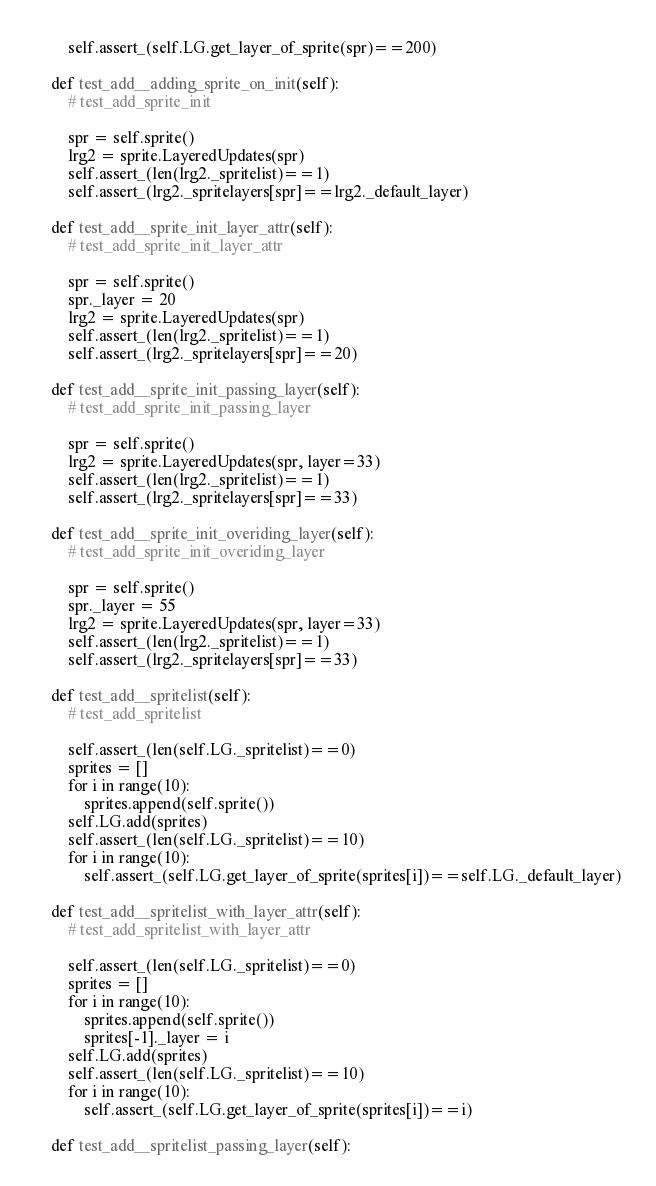Convert code to text. <code><loc_0><loc_0><loc_500><loc_500><_Python_>        self.assert_(self.LG.get_layer_of_sprite(spr)==200)

    def test_add__adding_sprite_on_init(self):
        # test_add_sprite_init

        spr = self.sprite()
        lrg2 = sprite.LayeredUpdates(spr)
        self.assert_(len(lrg2._spritelist)==1)
        self.assert_(lrg2._spritelayers[spr]==lrg2._default_layer)

    def test_add__sprite_init_layer_attr(self):
        # test_add_sprite_init_layer_attr

        spr = self.sprite()
        spr._layer = 20
        lrg2 = sprite.LayeredUpdates(spr)
        self.assert_(len(lrg2._spritelist)==1)
        self.assert_(lrg2._spritelayers[spr]==20)

    def test_add__sprite_init_passing_layer(self):
        # test_add_sprite_init_passing_layer

        spr = self.sprite()
        lrg2 = sprite.LayeredUpdates(spr, layer=33)
        self.assert_(len(lrg2._spritelist)==1)
        self.assert_(lrg2._spritelayers[spr]==33)

    def test_add__sprite_init_overiding_layer(self):
        # test_add_sprite_init_overiding_layer

        spr = self.sprite()
        spr._layer = 55
        lrg2 = sprite.LayeredUpdates(spr, layer=33)
        self.assert_(len(lrg2._spritelist)==1)
        self.assert_(lrg2._spritelayers[spr]==33)

    def test_add__spritelist(self):
        # test_add_spritelist

        self.assert_(len(self.LG._spritelist)==0)
        sprites = []
        for i in range(10):
            sprites.append(self.sprite())
        self.LG.add(sprites)
        self.assert_(len(self.LG._spritelist)==10)
        for i in range(10):
            self.assert_(self.LG.get_layer_of_sprite(sprites[i])==self.LG._default_layer)

    def test_add__spritelist_with_layer_attr(self):
        # test_add_spritelist_with_layer_attr

        self.assert_(len(self.LG._spritelist)==0)
        sprites = []
        for i in range(10):
            sprites.append(self.sprite())
            sprites[-1]._layer = i
        self.LG.add(sprites)
        self.assert_(len(self.LG._spritelist)==10)
        for i in range(10):
            self.assert_(self.LG.get_layer_of_sprite(sprites[i])==i)

    def test_add__spritelist_passing_layer(self):</code> 